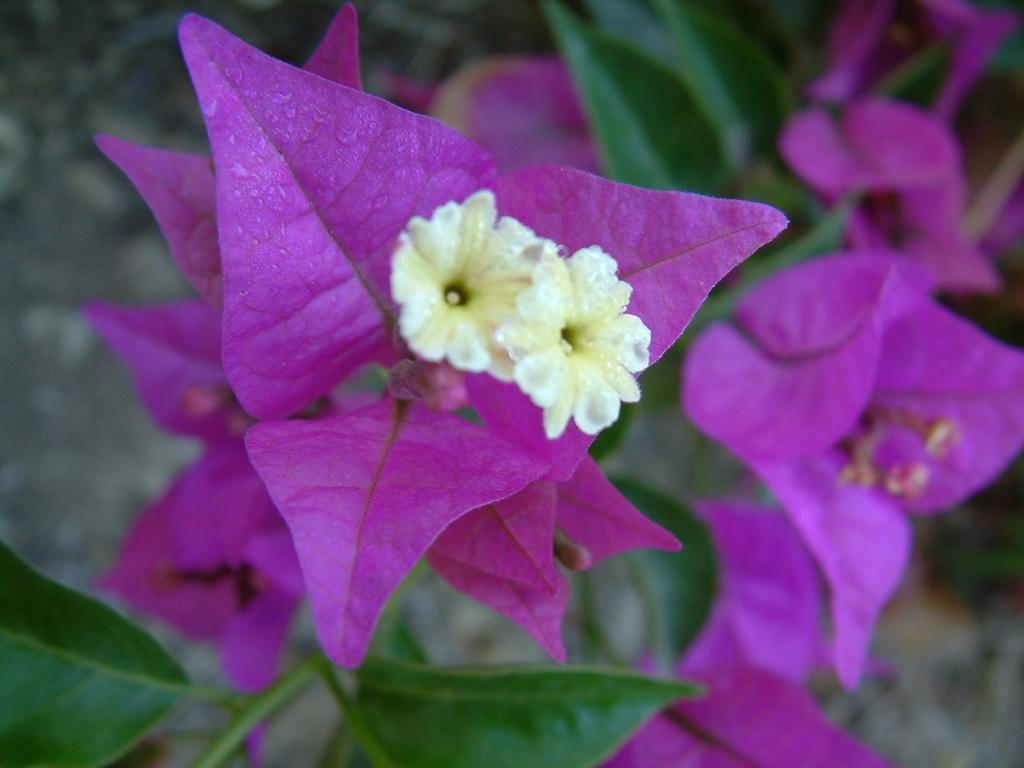Please provide a concise description of this image. In this image I see the flowers which are of pink and white in color and I see the green leaves on the stems and it is blurred in the background. 